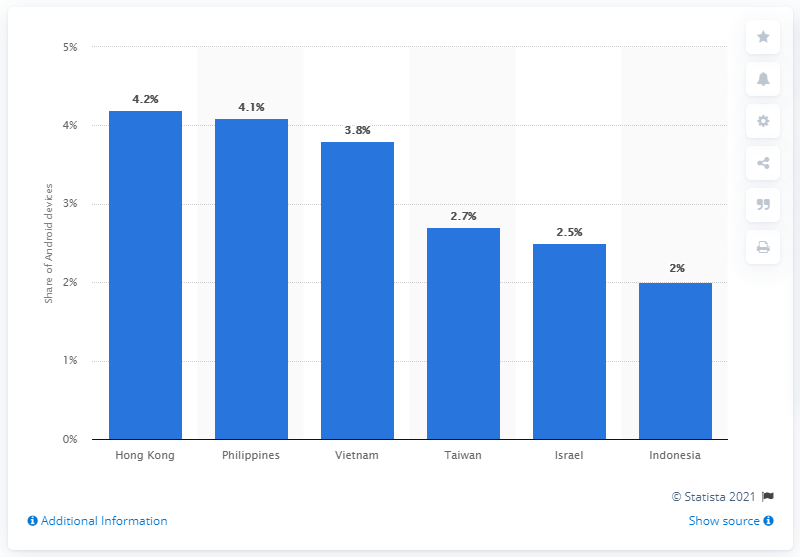Outline some significant characteristics in this image. According to data from Hong Kong, approximately 4.2% of all Android devices had Pokémon GO installed. 